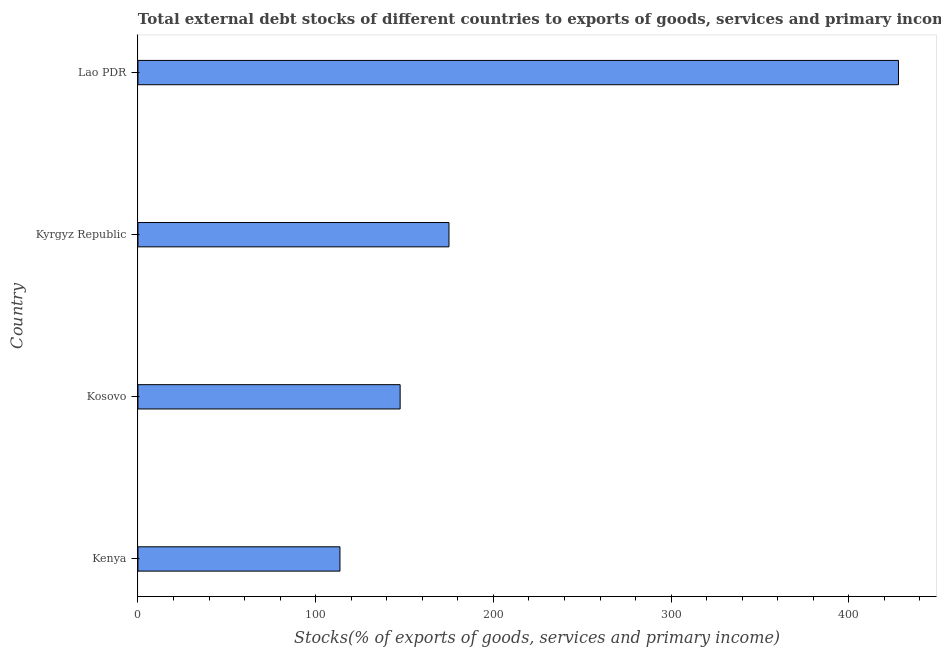What is the title of the graph?
Provide a succinct answer. Total external debt stocks of different countries to exports of goods, services and primary income in 2009. What is the label or title of the X-axis?
Your response must be concise. Stocks(% of exports of goods, services and primary income). What is the label or title of the Y-axis?
Your answer should be compact. Country. What is the external debt stocks in Kosovo?
Give a very brief answer. 147.52. Across all countries, what is the maximum external debt stocks?
Keep it short and to the point. 427.9. Across all countries, what is the minimum external debt stocks?
Make the answer very short. 113.66. In which country was the external debt stocks maximum?
Give a very brief answer. Lao PDR. In which country was the external debt stocks minimum?
Your answer should be very brief. Kenya. What is the sum of the external debt stocks?
Provide a short and direct response. 864.07. What is the difference between the external debt stocks in Kenya and Lao PDR?
Ensure brevity in your answer.  -314.24. What is the average external debt stocks per country?
Your answer should be very brief. 216.02. What is the median external debt stocks?
Your answer should be very brief. 161.26. In how many countries, is the external debt stocks greater than 320 %?
Your answer should be compact. 1. What is the ratio of the external debt stocks in Kenya to that in Kyrgyz Republic?
Your answer should be very brief. 0.65. Is the difference between the external debt stocks in Kenya and Kosovo greater than the difference between any two countries?
Make the answer very short. No. What is the difference between the highest and the second highest external debt stocks?
Provide a short and direct response. 252.9. Is the sum of the external debt stocks in Kosovo and Kyrgyz Republic greater than the maximum external debt stocks across all countries?
Offer a terse response. No. What is the difference between the highest and the lowest external debt stocks?
Your answer should be very brief. 314.24. How many countries are there in the graph?
Ensure brevity in your answer.  4. What is the Stocks(% of exports of goods, services and primary income) of Kenya?
Your answer should be very brief. 113.66. What is the Stocks(% of exports of goods, services and primary income) of Kosovo?
Your answer should be compact. 147.52. What is the Stocks(% of exports of goods, services and primary income) in Kyrgyz Republic?
Offer a very short reply. 175. What is the Stocks(% of exports of goods, services and primary income) of Lao PDR?
Ensure brevity in your answer.  427.9. What is the difference between the Stocks(% of exports of goods, services and primary income) in Kenya and Kosovo?
Your response must be concise. -33.86. What is the difference between the Stocks(% of exports of goods, services and primary income) in Kenya and Kyrgyz Republic?
Ensure brevity in your answer.  -61.34. What is the difference between the Stocks(% of exports of goods, services and primary income) in Kenya and Lao PDR?
Ensure brevity in your answer.  -314.24. What is the difference between the Stocks(% of exports of goods, services and primary income) in Kosovo and Kyrgyz Republic?
Keep it short and to the point. -27.48. What is the difference between the Stocks(% of exports of goods, services and primary income) in Kosovo and Lao PDR?
Offer a terse response. -280.38. What is the difference between the Stocks(% of exports of goods, services and primary income) in Kyrgyz Republic and Lao PDR?
Provide a succinct answer. -252.9. What is the ratio of the Stocks(% of exports of goods, services and primary income) in Kenya to that in Kosovo?
Make the answer very short. 0.77. What is the ratio of the Stocks(% of exports of goods, services and primary income) in Kenya to that in Kyrgyz Republic?
Offer a terse response. 0.65. What is the ratio of the Stocks(% of exports of goods, services and primary income) in Kenya to that in Lao PDR?
Ensure brevity in your answer.  0.27. What is the ratio of the Stocks(% of exports of goods, services and primary income) in Kosovo to that in Kyrgyz Republic?
Your response must be concise. 0.84. What is the ratio of the Stocks(% of exports of goods, services and primary income) in Kosovo to that in Lao PDR?
Offer a terse response. 0.34. What is the ratio of the Stocks(% of exports of goods, services and primary income) in Kyrgyz Republic to that in Lao PDR?
Your answer should be compact. 0.41. 